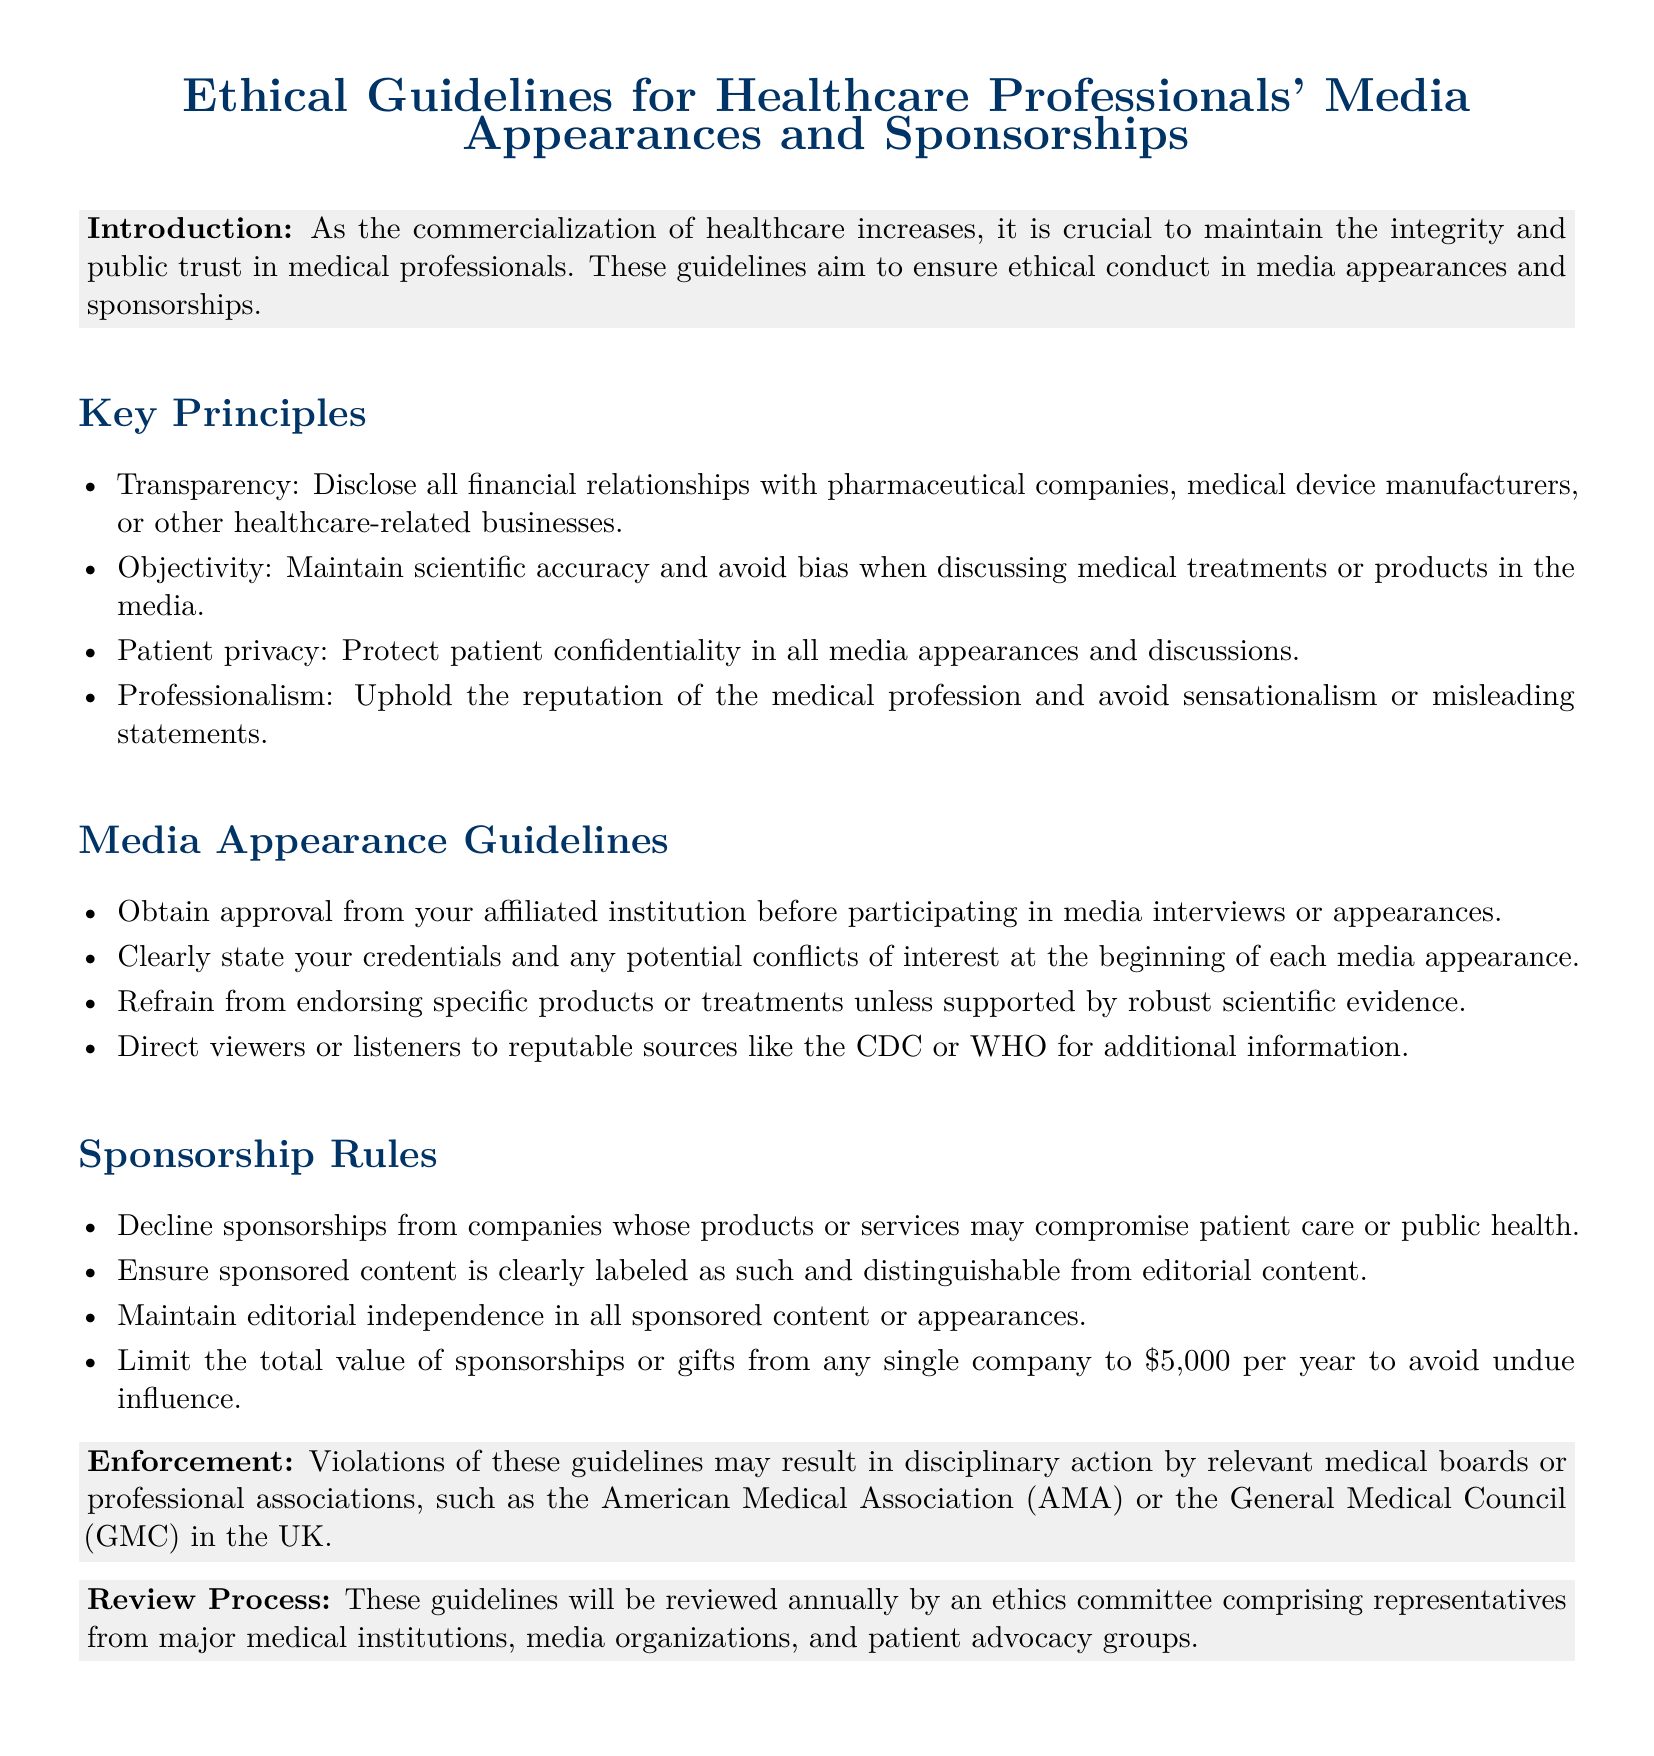What is the title of the document? The title is the main heading of the document, prominently displayed.
Answer: Ethical Guidelines for Healthcare Professionals' Media Appearances and Sponsorships What should be disclosed in media appearances? This information pertains to financial relationships with companies and is highlighted under Key Principles.
Answer: All financial relationships What is the maximum value of sponsorships from a single company? This information is specified in the Sponsorship Rules section of the document.
Answer: $5,000 Who must approve participation in media interviews? This question relates to the Media Appearance Guidelines section of the document.
Answer: Affiliated institution What is the purpose of these guidelines? This part of the document explains the overall intent behind the guidelines.
Answer: Maintain integrity and public trust Which organizations may take disciplinary action for guideline violations? This information is found in the Enforcement section of the document.
Answer: Medical boards or professional associations What is required at the beginning of each media appearance? This refers to an essential practice outlined in the Media Appearance Guidelines section.
Answer: State credentials and conflicts of interest How often will these guidelines be reviewed? The Review Process section specifies the frequency of guideline evaluations.
Answer: Annually 